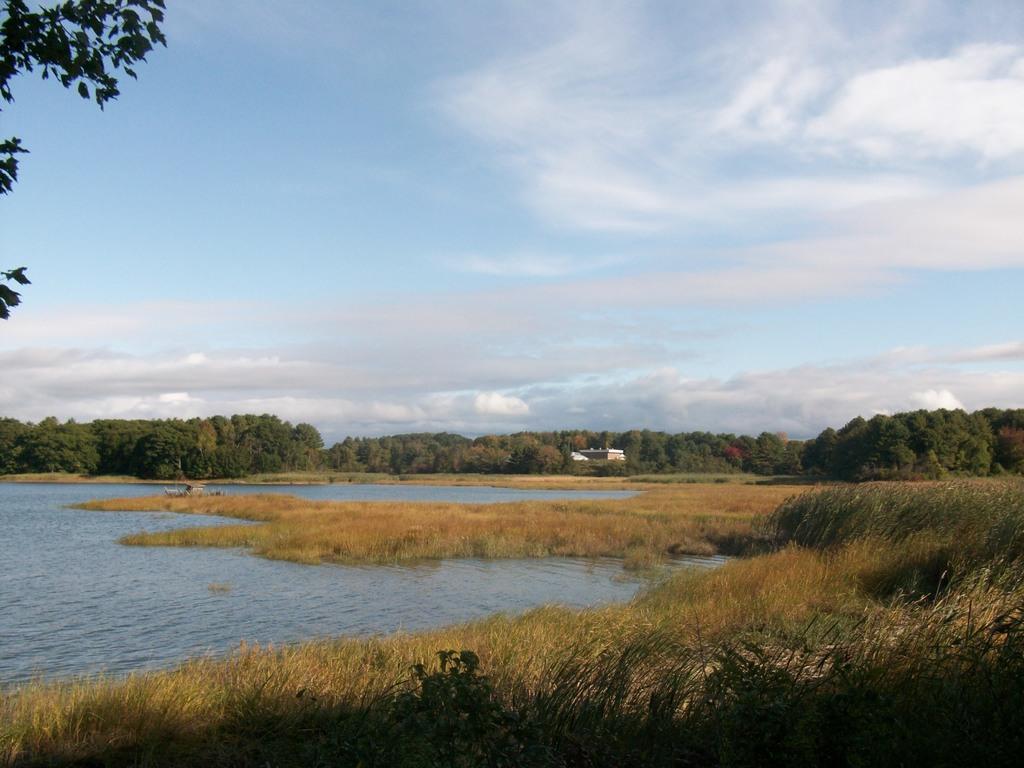In one or two sentences, can you explain what this image depicts? In this image, we can see some grass, plants, trees. We can see an object and the sky with clouds. We can also see some water and some leaves on the left. 